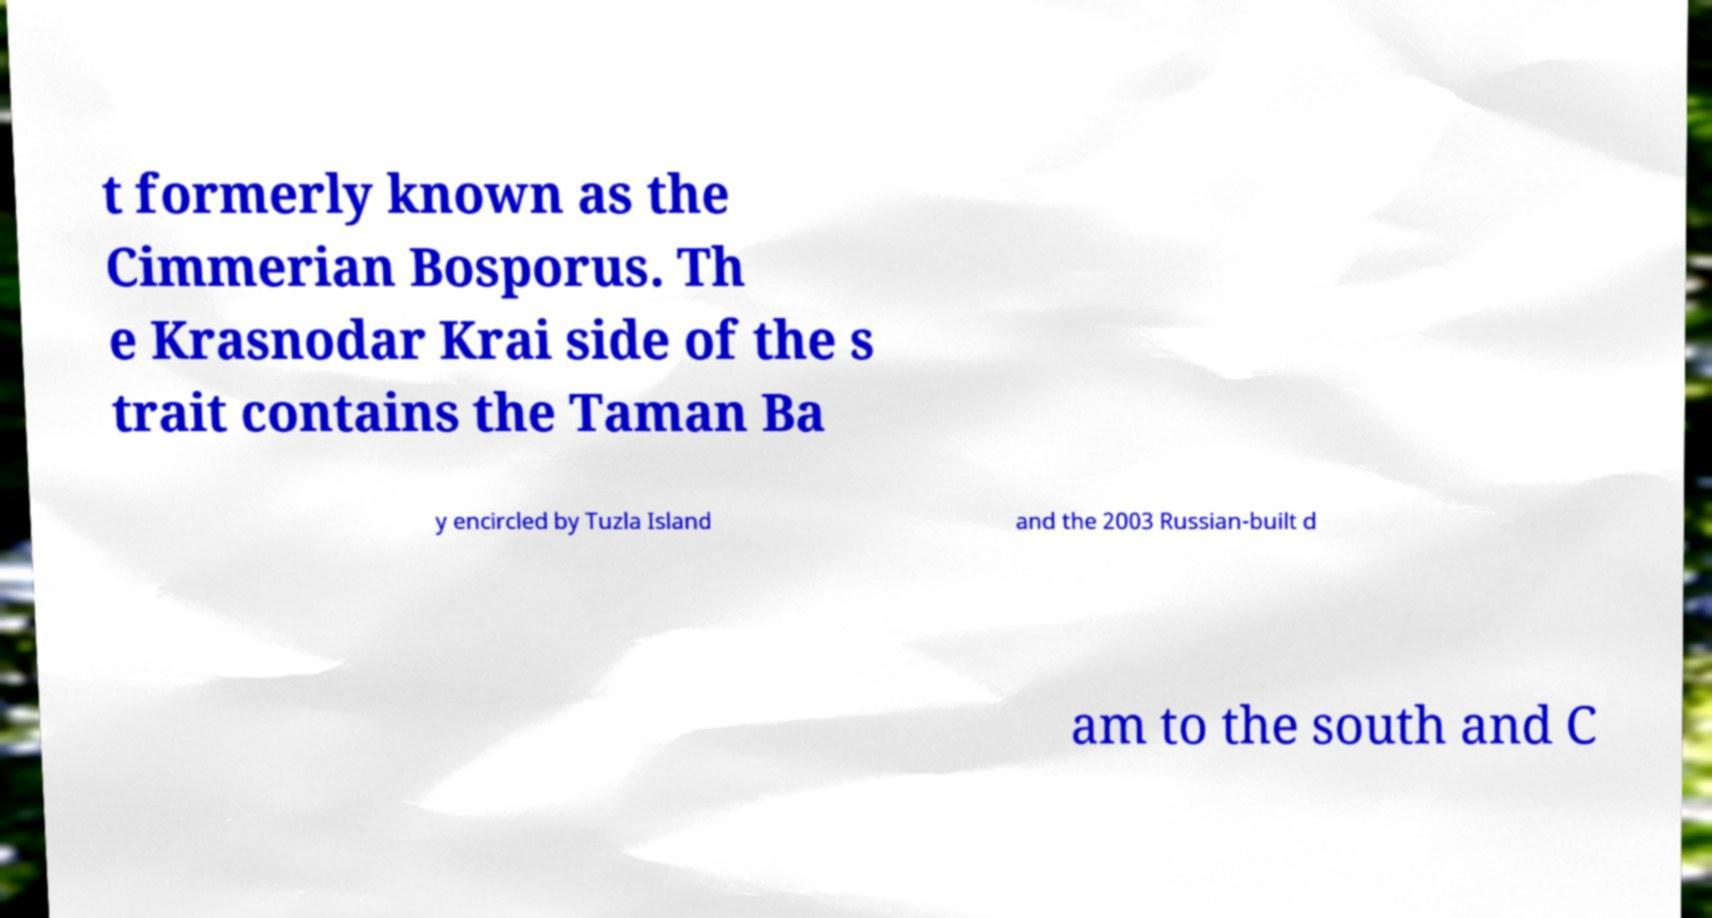Could you assist in decoding the text presented in this image and type it out clearly? t formerly known as the Cimmerian Bosporus. Th e Krasnodar Krai side of the s trait contains the Taman Ba y encircled by Tuzla Island and the 2003 Russian-built d am to the south and C 